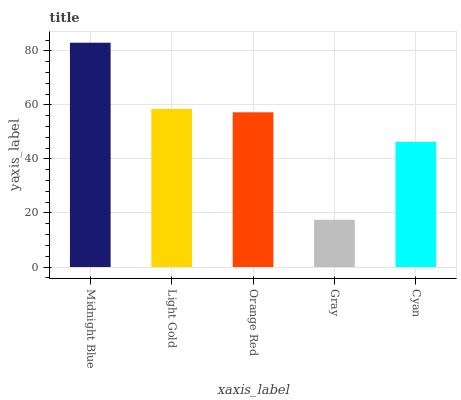Is Light Gold the minimum?
Answer yes or no. No. Is Light Gold the maximum?
Answer yes or no. No. Is Midnight Blue greater than Light Gold?
Answer yes or no. Yes. Is Light Gold less than Midnight Blue?
Answer yes or no. Yes. Is Light Gold greater than Midnight Blue?
Answer yes or no. No. Is Midnight Blue less than Light Gold?
Answer yes or no. No. Is Orange Red the high median?
Answer yes or no. Yes. Is Orange Red the low median?
Answer yes or no. Yes. Is Light Gold the high median?
Answer yes or no. No. Is Gray the low median?
Answer yes or no. No. 